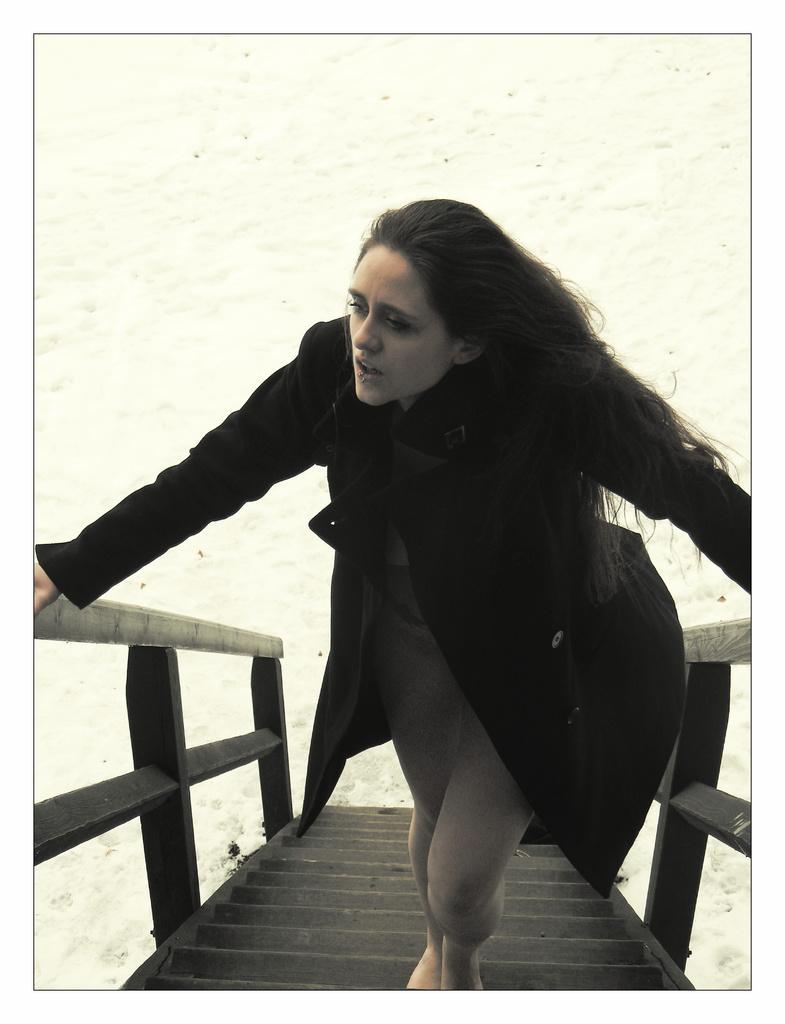In one or two sentences, can you explain what this image depicts? In this picture we can see a woman standing on the wooden stairs and looking at someone. 